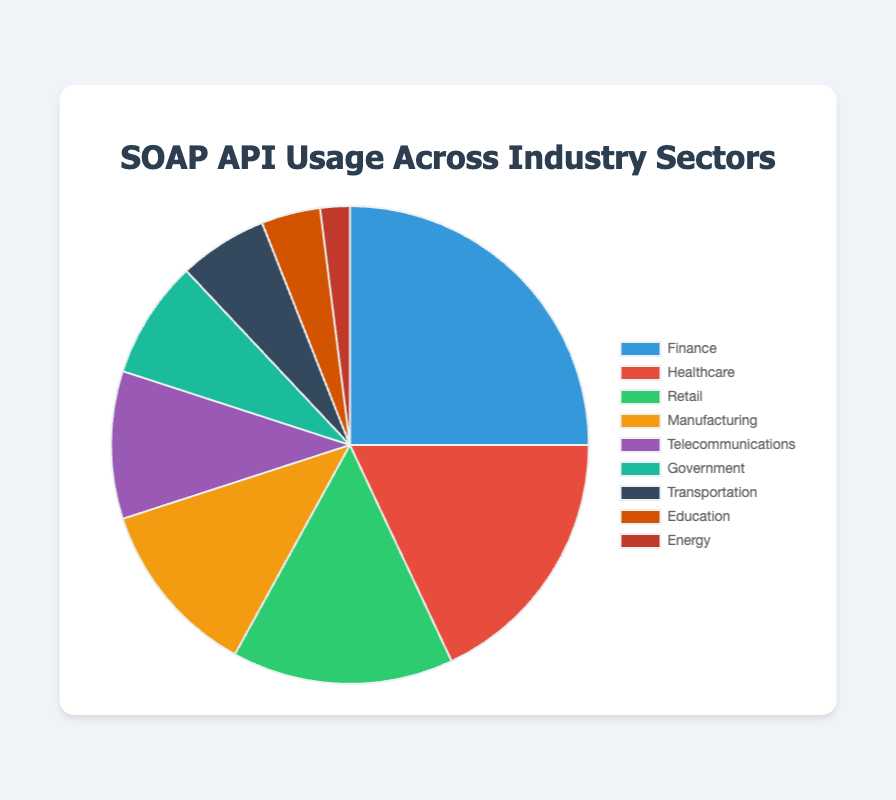Which industry sector has the highest SOAP API usage? From the pie chart, the "Finance" sector shows the largest slice, indicating it has the highest SOAP API usage percentage.
Answer: Finance Which industry has the second highest usage of SOAP APIs? The pie chart shows the "Healthcare" sector with the second largest slice, indicating it has the second highest SOAP API usage percentage.
Answer: Healthcare What is the total percentage usage of SOAP APIs in the Finance and Healthcare sectors combined? Adding the percentages for "Finance" (25%) and "Healthcare" (18%) gives the total: 25% + 18% = 43%.
Answer: 43% Which sector has the smallest usage of SOAP APIs and what is its percentage? The smallest slice in the pie chart represents the "Energy" sector, which has a usage of 2%.
Answer: Energy, 2% How does the SOAP API usage of the Telecommunications sector compare to the Retail sector? The pie chart shows that the "Telecommunications" sector has 10% usage, while the "Retail" sector has 15% usage. Thus, the Telecommunications sector uses SOAP APIs 5% less.
Answer: Telecommunications uses 5% less What is the median usage percentage of SOAP APIs across all sectors? Arranging the percentages in ascending order: 2, 4, 6, 8, 10, 12, 15, 18, 25. The median value is the fifth number: 10%.
Answer: 10% Combine the usage percentages of sectors with less than 10% usage. What is the total? Adding the percentages of "Government" (8%), "Transportation" (6%), "Education" (4%), and "Energy" (2%) gives: 8% + 6% + 4% + 2% = 20%.
Answer: 20% How much more SOAP API usage does the Finance sector have compared to the Manufacturing sector? The Finance sector has 25% and the Manufacturing sector has 12%. Subtracting these gives: 25% - 12% = 13%.
Answer: 13% Which two sectors combined have the same usage percentage as the Retail sector? The "Government" (8%) and "Transportation" (6%) sectors combined have a total of 8% + 6% = 14%. Although not equal, this is the closest to the "Retail" sector's 15%.
Answer: Government and Transportation 